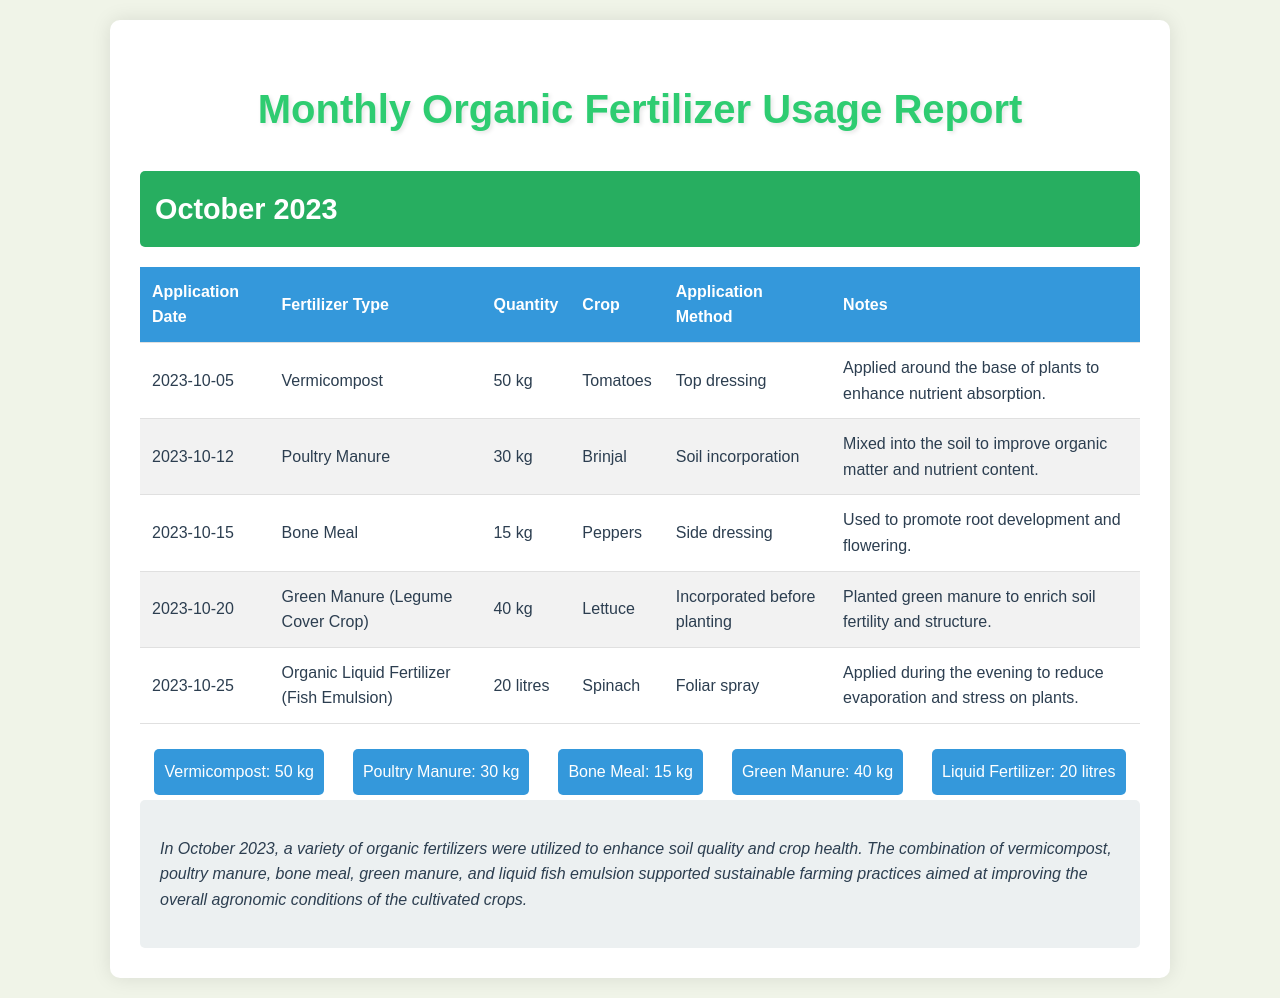What is the application date for Vermicompost? The application date for Vermicompost is listed in the table, specifically under the "Application Date" column for that row.
Answer: 2023-10-05 How much Poultry Manure was used? The quantity of Poultry Manure is specified in the table under the "Quantity" column for Poultry Manure.
Answer: 30 kg What crop was Bone Meal applied to? The crop associated with Bone Meal can be found in the "Crop" column next to the Bone Meal entry in the table.
Answer: Peppers Which application method was used for Green Manure? The method used for Green Manure is indicated in the "Application Method" column for that row in the document.
Answer: Incorporated before planting What is the total quantity of Organic Liquid Fertilizer used? To find the total quantity, we look at the "Quantity" column for the Organic Liquid Fertilizer row in the table.
Answer: 20 litres How many different types of organic fertilizers are listed? The total number of different organic fertilizers can be determined by counting the unique entries in the "Fertilizer Type" column of the table.
Answer: 5 What was the purpose of applying Vermicompost? The purpose can be deduced from the "Notes" column corresponding to Vermicompost in the table.
Answer: Enhance nutrient absorption On which date was the last organic fertilizer applied? The date of the last organic fertilizer application can be found by locating the last entry in the "Application Date" column of the table.
Answer: 2023-10-25 What is the main focus of this Monthly Organic Fertilizer Usage Report? The main focus of the report is summarized in the section that highlights the overall aim of the applied fertilizers as described in the summary paragraph.
Answer: Sustainable farming practices 